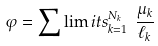Convert formula to latex. <formula><loc_0><loc_0><loc_500><loc_500>\varphi = \sum \lim i t s _ { k = 1 } ^ { N _ { k } } \ \frac { { \mu } _ { k } } { { \ell } _ { k } }</formula> 